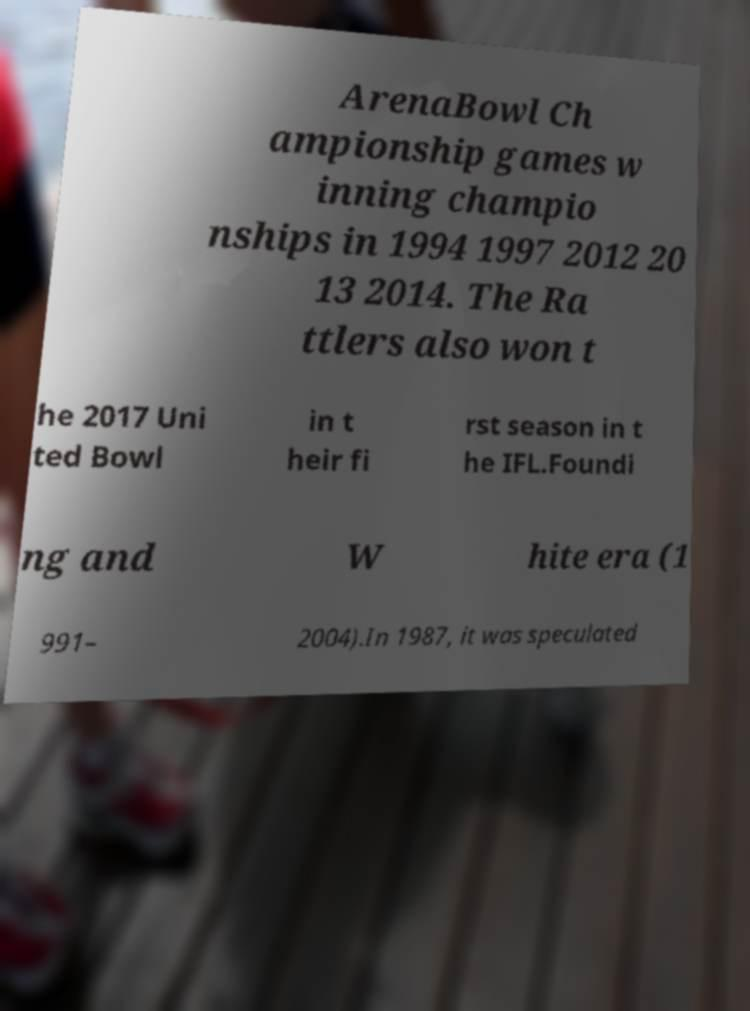For documentation purposes, I need the text within this image transcribed. Could you provide that? ArenaBowl Ch ampionship games w inning champio nships in 1994 1997 2012 20 13 2014. The Ra ttlers also won t he 2017 Uni ted Bowl in t heir fi rst season in t he IFL.Foundi ng and W hite era (1 991– 2004).In 1987, it was speculated 